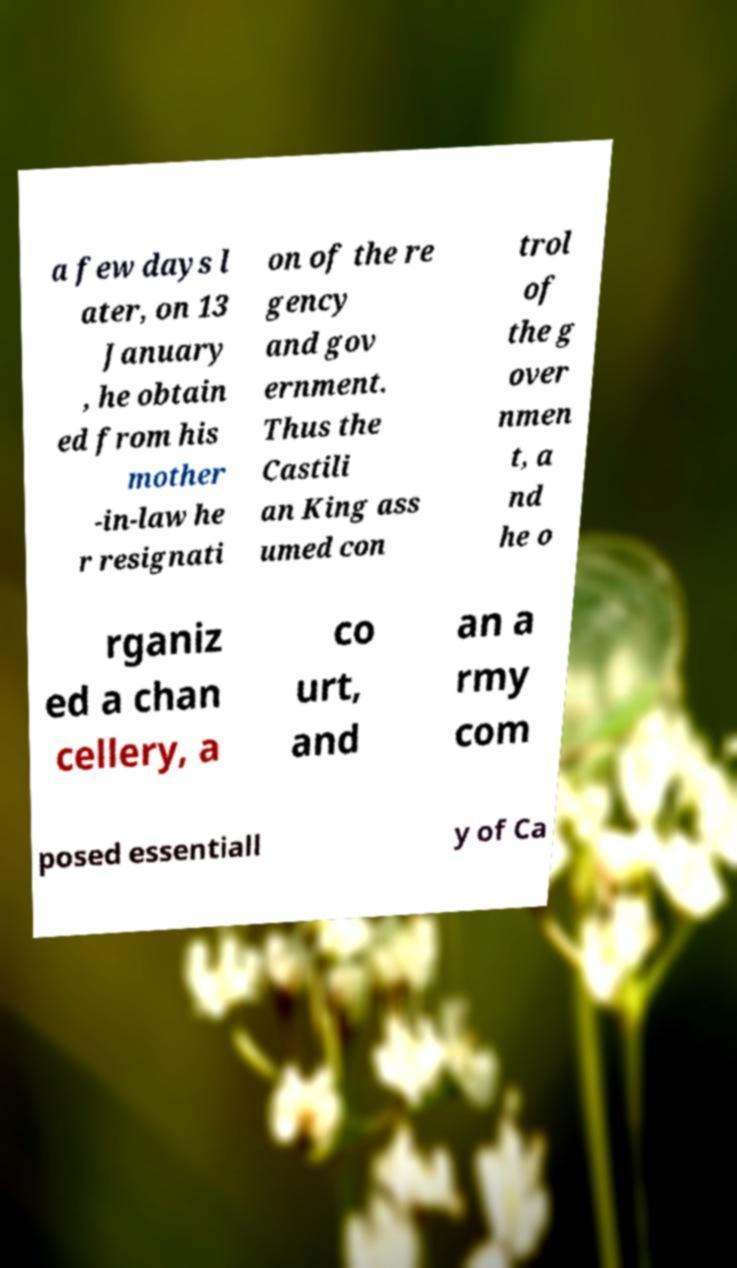Could you assist in decoding the text presented in this image and type it out clearly? a few days l ater, on 13 January , he obtain ed from his mother -in-law he r resignati on of the re gency and gov ernment. Thus the Castili an King ass umed con trol of the g over nmen t, a nd he o rganiz ed a chan cellery, a co urt, and an a rmy com posed essentiall y of Ca 